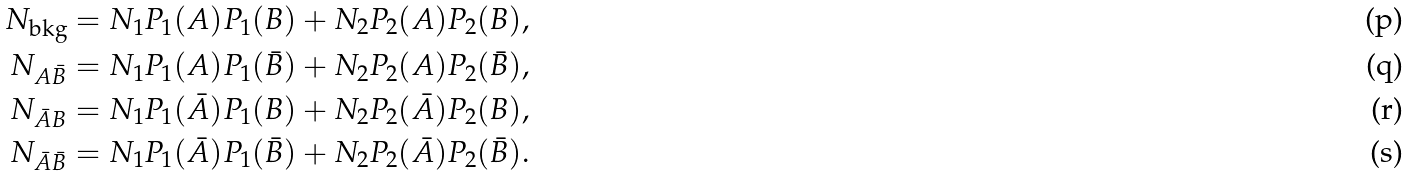<formula> <loc_0><loc_0><loc_500><loc_500>N _ { \text {bkg} } = N _ { 1 } P _ { 1 } ( A ) P _ { 1 } ( B ) + N _ { 2 } P _ { 2 } ( A ) P _ { 2 } ( B ) , \\ N _ { A \bar { B } } = N _ { 1 } P _ { 1 } ( A ) P _ { 1 } ( \bar { B } ) + N _ { 2 } P _ { 2 } ( A ) P _ { 2 } ( \bar { B } ) , \\ N _ { \bar { A } B } = N _ { 1 } P _ { 1 } ( \bar { A } ) P _ { 1 } ( B ) + N _ { 2 } P _ { 2 } ( \bar { A } ) P _ { 2 } ( B ) , \\ N _ { \bar { A } \bar { B } } = N _ { 1 } P _ { 1 } ( \bar { A } ) P _ { 1 } ( \bar { B } ) + N _ { 2 } P _ { 2 } ( \bar { A } ) P _ { 2 } ( \bar { B } ) .</formula> 